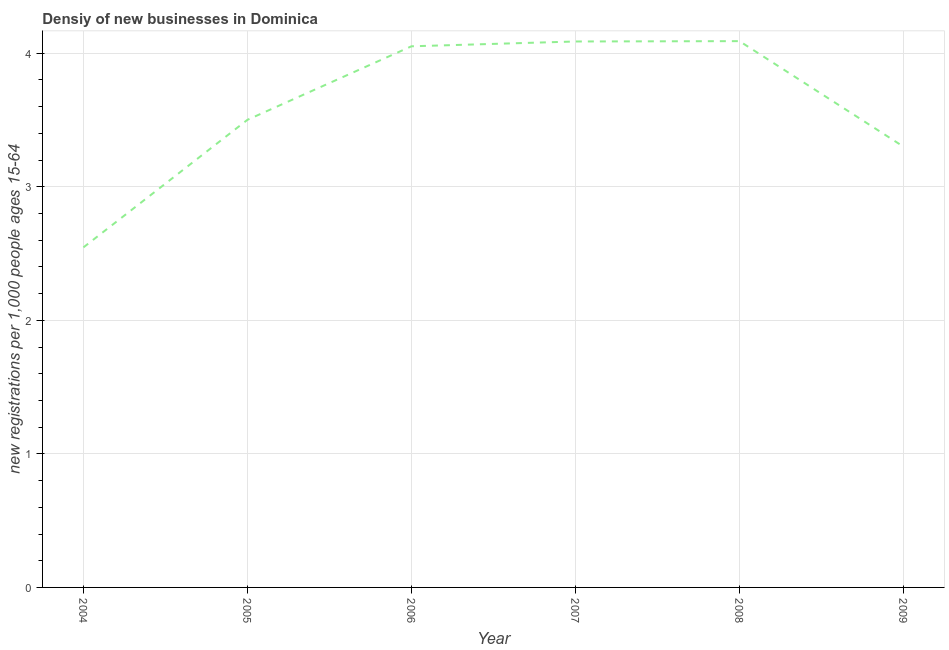What is the density of new business in 2004?
Make the answer very short. 2.55. Across all years, what is the maximum density of new business?
Offer a very short reply. 4.09. Across all years, what is the minimum density of new business?
Offer a very short reply. 2.55. In which year was the density of new business minimum?
Make the answer very short. 2004. What is the sum of the density of new business?
Your answer should be compact. 21.58. What is the difference between the density of new business in 2005 and 2006?
Ensure brevity in your answer.  -0.55. What is the average density of new business per year?
Your response must be concise. 3.6. What is the median density of new business?
Your response must be concise. 3.78. What is the ratio of the density of new business in 2008 to that in 2009?
Your answer should be very brief. 1.24. What is the difference between the highest and the second highest density of new business?
Your answer should be compact. 0. What is the difference between the highest and the lowest density of new business?
Your answer should be compact. 1.54. How many lines are there?
Provide a short and direct response. 1. How many years are there in the graph?
Your answer should be very brief. 6. What is the difference between two consecutive major ticks on the Y-axis?
Offer a terse response. 1. Are the values on the major ticks of Y-axis written in scientific E-notation?
Give a very brief answer. No. Does the graph contain any zero values?
Keep it short and to the point. No. Does the graph contain grids?
Your response must be concise. Yes. What is the title of the graph?
Make the answer very short. Densiy of new businesses in Dominica. What is the label or title of the Y-axis?
Provide a short and direct response. New registrations per 1,0 people ages 15-64. What is the new registrations per 1,000 people ages 15-64 in 2004?
Make the answer very short. 2.55. What is the new registrations per 1,000 people ages 15-64 in 2005?
Give a very brief answer. 3.5. What is the new registrations per 1,000 people ages 15-64 in 2006?
Your answer should be compact. 4.05. What is the new registrations per 1,000 people ages 15-64 in 2007?
Provide a short and direct response. 4.09. What is the new registrations per 1,000 people ages 15-64 in 2008?
Offer a very short reply. 4.09. What is the difference between the new registrations per 1,000 people ages 15-64 in 2004 and 2005?
Your answer should be very brief. -0.96. What is the difference between the new registrations per 1,000 people ages 15-64 in 2004 and 2006?
Provide a short and direct response. -1.51. What is the difference between the new registrations per 1,000 people ages 15-64 in 2004 and 2007?
Keep it short and to the point. -1.54. What is the difference between the new registrations per 1,000 people ages 15-64 in 2004 and 2008?
Offer a terse response. -1.54. What is the difference between the new registrations per 1,000 people ages 15-64 in 2004 and 2009?
Provide a short and direct response. -0.75. What is the difference between the new registrations per 1,000 people ages 15-64 in 2005 and 2006?
Your answer should be compact. -0.55. What is the difference between the new registrations per 1,000 people ages 15-64 in 2005 and 2007?
Your response must be concise. -0.59. What is the difference between the new registrations per 1,000 people ages 15-64 in 2005 and 2008?
Provide a short and direct response. -0.59. What is the difference between the new registrations per 1,000 people ages 15-64 in 2005 and 2009?
Offer a very short reply. 0.2. What is the difference between the new registrations per 1,000 people ages 15-64 in 2006 and 2007?
Your answer should be compact. -0.04. What is the difference between the new registrations per 1,000 people ages 15-64 in 2006 and 2008?
Offer a very short reply. -0.04. What is the difference between the new registrations per 1,000 people ages 15-64 in 2006 and 2009?
Offer a very short reply. 0.75. What is the difference between the new registrations per 1,000 people ages 15-64 in 2007 and 2008?
Make the answer very short. -0. What is the difference between the new registrations per 1,000 people ages 15-64 in 2007 and 2009?
Ensure brevity in your answer.  0.79. What is the difference between the new registrations per 1,000 people ages 15-64 in 2008 and 2009?
Your answer should be compact. 0.79. What is the ratio of the new registrations per 1,000 people ages 15-64 in 2004 to that in 2005?
Ensure brevity in your answer.  0.73. What is the ratio of the new registrations per 1,000 people ages 15-64 in 2004 to that in 2006?
Offer a very short reply. 0.63. What is the ratio of the new registrations per 1,000 people ages 15-64 in 2004 to that in 2007?
Provide a succinct answer. 0.62. What is the ratio of the new registrations per 1,000 people ages 15-64 in 2004 to that in 2008?
Make the answer very short. 0.62. What is the ratio of the new registrations per 1,000 people ages 15-64 in 2004 to that in 2009?
Make the answer very short. 0.77. What is the ratio of the new registrations per 1,000 people ages 15-64 in 2005 to that in 2006?
Offer a terse response. 0.86. What is the ratio of the new registrations per 1,000 people ages 15-64 in 2005 to that in 2007?
Your answer should be very brief. 0.86. What is the ratio of the new registrations per 1,000 people ages 15-64 in 2005 to that in 2008?
Offer a very short reply. 0.86. What is the ratio of the new registrations per 1,000 people ages 15-64 in 2005 to that in 2009?
Your answer should be very brief. 1.06. What is the ratio of the new registrations per 1,000 people ages 15-64 in 2006 to that in 2007?
Give a very brief answer. 0.99. What is the ratio of the new registrations per 1,000 people ages 15-64 in 2006 to that in 2009?
Make the answer very short. 1.23. What is the ratio of the new registrations per 1,000 people ages 15-64 in 2007 to that in 2009?
Keep it short and to the point. 1.24. What is the ratio of the new registrations per 1,000 people ages 15-64 in 2008 to that in 2009?
Your answer should be very brief. 1.24. 